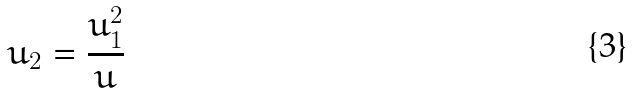<formula> <loc_0><loc_0><loc_500><loc_500>u _ { 2 } = \frac { u _ { 1 } ^ { 2 } } { u }</formula> 